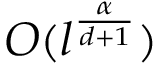Convert formula to latex. <formula><loc_0><loc_0><loc_500><loc_500>O ( l ^ { \frac { \alpha } { d + 1 } } )</formula> 